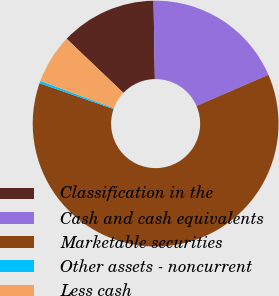Convert chart. <chart><loc_0><loc_0><loc_500><loc_500><pie_chart><fcel>Classification in the<fcel>Cash and cash equivalents<fcel>Marketable securities<fcel>Other assets - noncurrent<fcel>Less cash<nl><fcel>12.62%<fcel>18.77%<fcel>61.82%<fcel>0.32%<fcel>6.47%<nl></chart> 